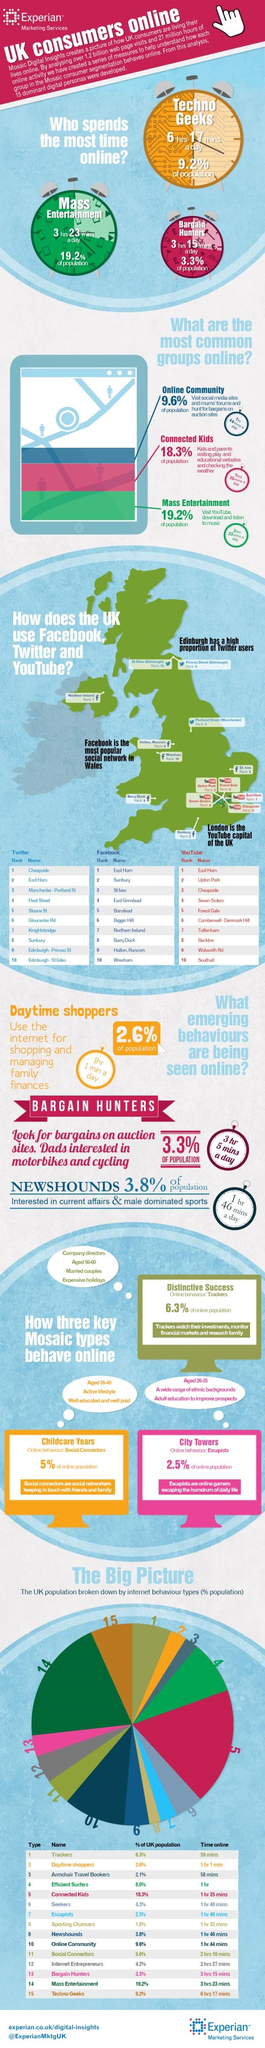Outline some significant characteristics in this image. The color used to represent the second most common group online is blue, green, or red. The color most commonly associated with online groups is green. The third graphic in this infographic visualizes the behavior of escapees, which refers to individuals who have successfully transitioned from one stage of the DevOps journey to the next, effectively escaping from lower stages and moving towards higher ones. The second emerging behavior seen online is bargain hunting. Approximately 6.8% of individuals can be classified as both seekers and escapists based on their responses to the survey questions. 